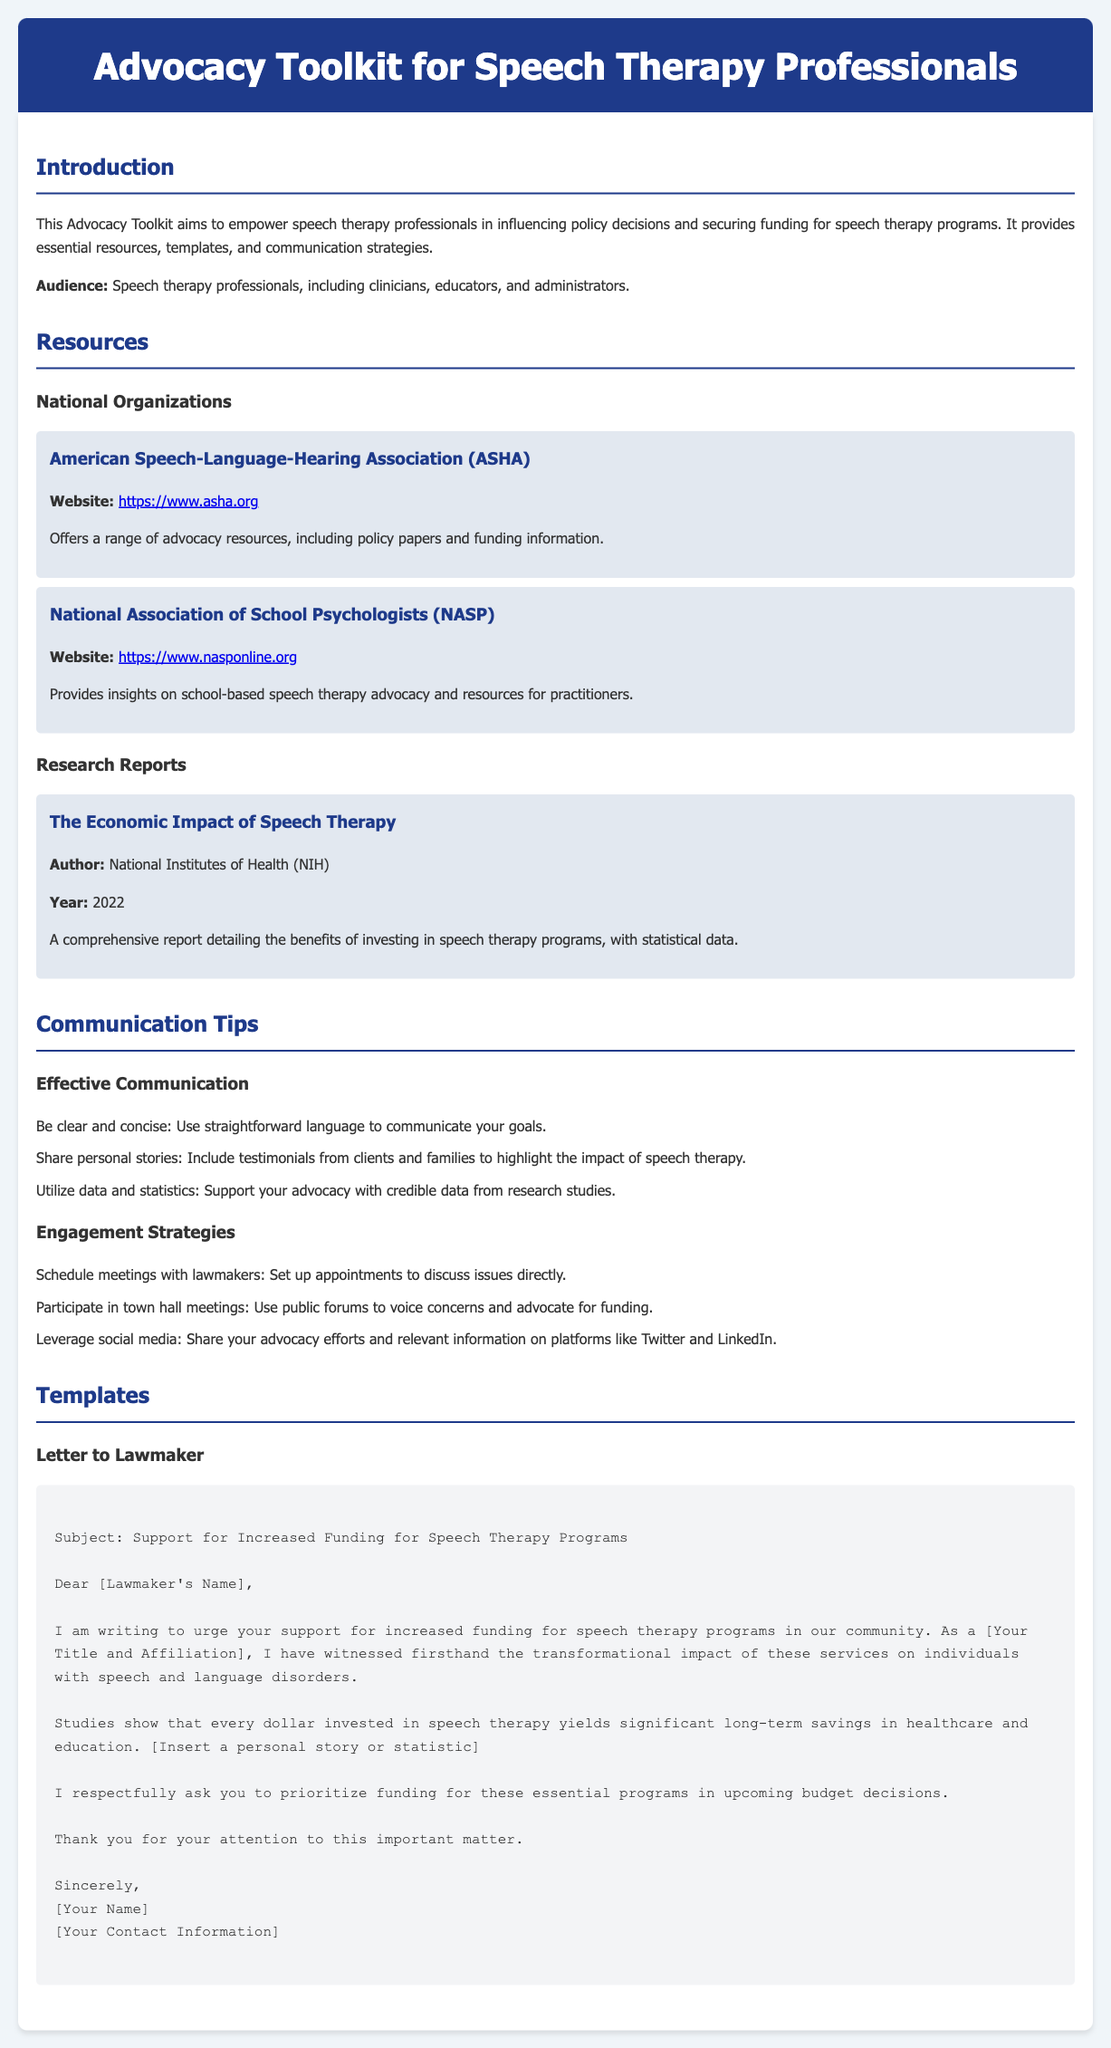what is the purpose of the Advocacy Toolkit? The purpose of the Advocacy Toolkit is to empower speech therapy professionals in influencing policy decisions and securing funding for speech therapy programs.
Answer: to empower speech therapy professionals who is the target audience for this toolkit? The target audience includes speech therapy professionals, specifically clinicians, educators, and administrators.
Answer: speech therapy professionals what organization provides advocacy resources mentioned in the document? The American Speech-Language-Hearing Association (ASHA) offers a range of advocacy resources including policy papers and funding information.
Answer: American Speech-Language-Hearing Association (ASHA) what year was the report on the economic impact of speech therapy published? The report detailing the benefits of investing in speech therapy programs was published in 2022.
Answer: 2022 what is the subject of the template letter to lawmakers? The subject of the letter is support for increased funding for speech therapy programs.
Answer: Support for Increased Funding for Speech Therapy Programs name one engagement strategy mentioned in the document. Scheduling meetings with lawmakers is one of the engagement strategies listed for effective advocacy.
Answer: Schedule meetings with lawmakers what type of stories should be included to support advocacy? Personal stories should be shared to highlight the impact of speech therapy.
Answer: Personal stories which organization offers insights on school-based speech therapy advocacy? The National Association of School Psychologists (NASP) provides insights on school-based speech therapy advocacy.
Answer: National Association of School Psychologists (NASP) 